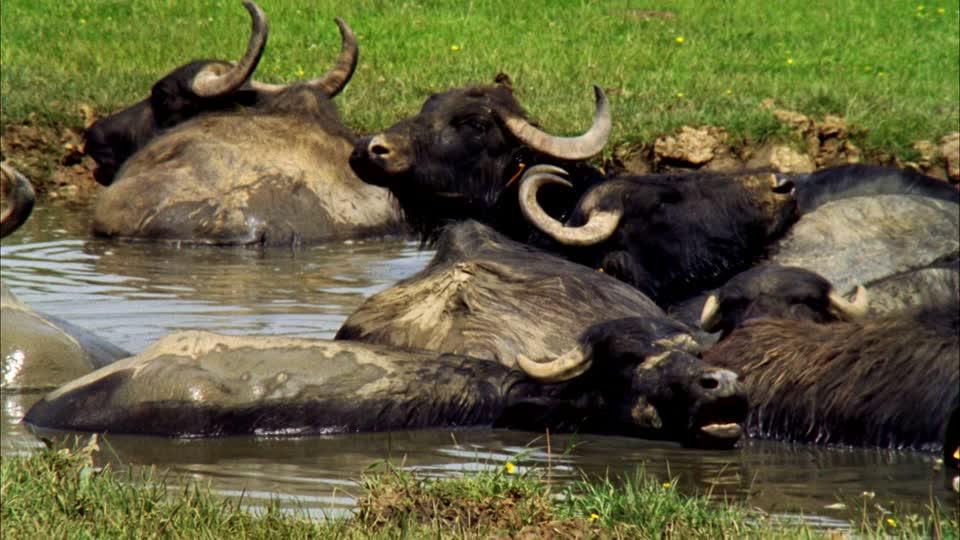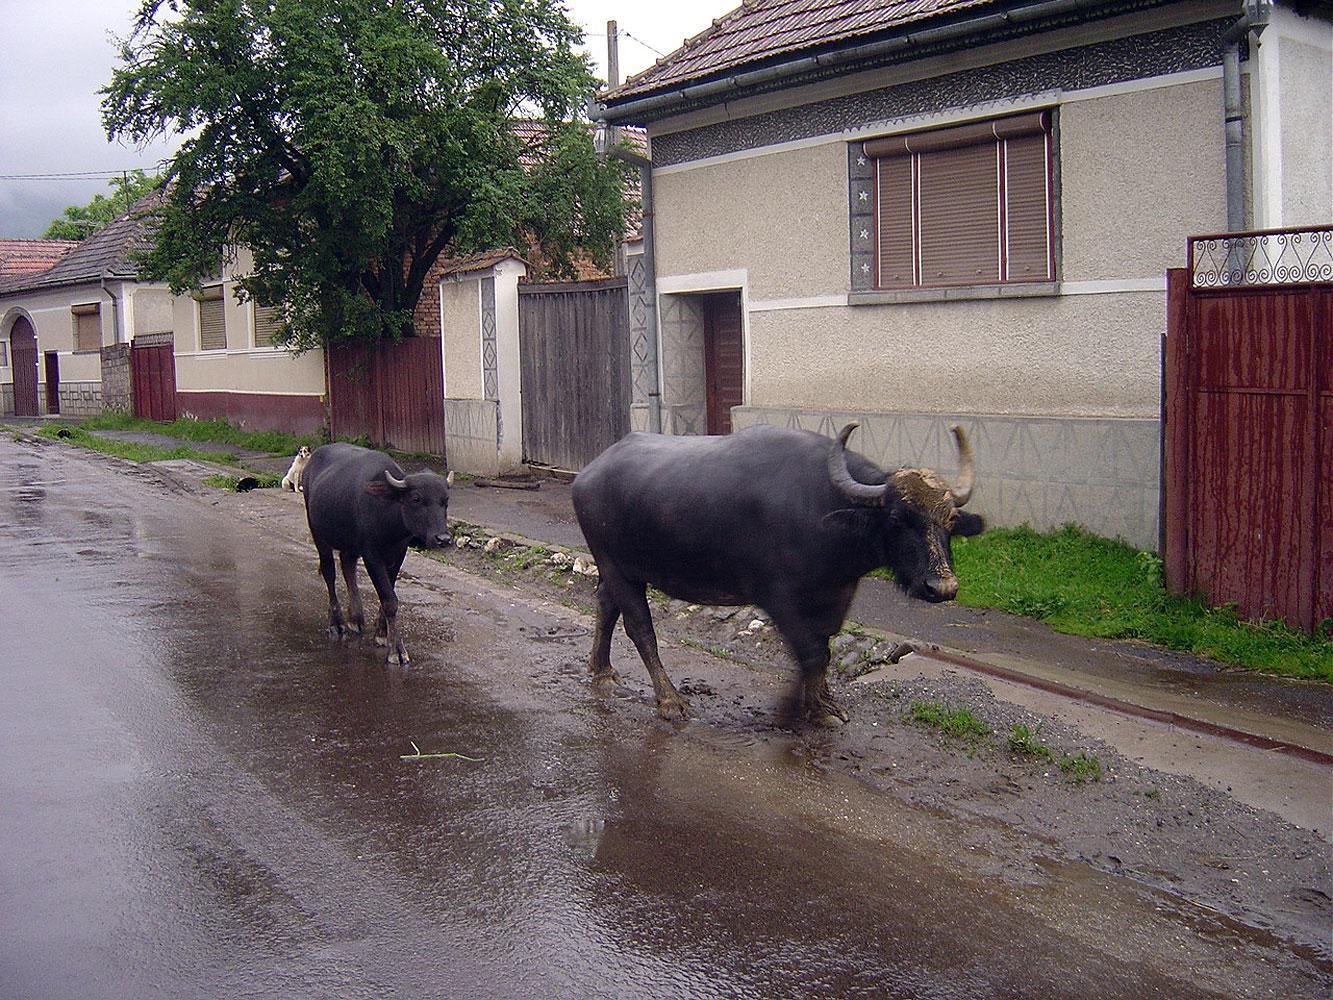The first image is the image on the left, the second image is the image on the right. For the images displayed, is the sentence "The right image contains at least one water buffalo walking through a town on a dirt road." factually correct? Answer yes or no. Yes. The first image is the image on the left, the second image is the image on the right. Given the left and right images, does the statement "In at least one image, water buffalo are walking rightward down a street lined with buildings." hold true? Answer yes or no. Yes. 